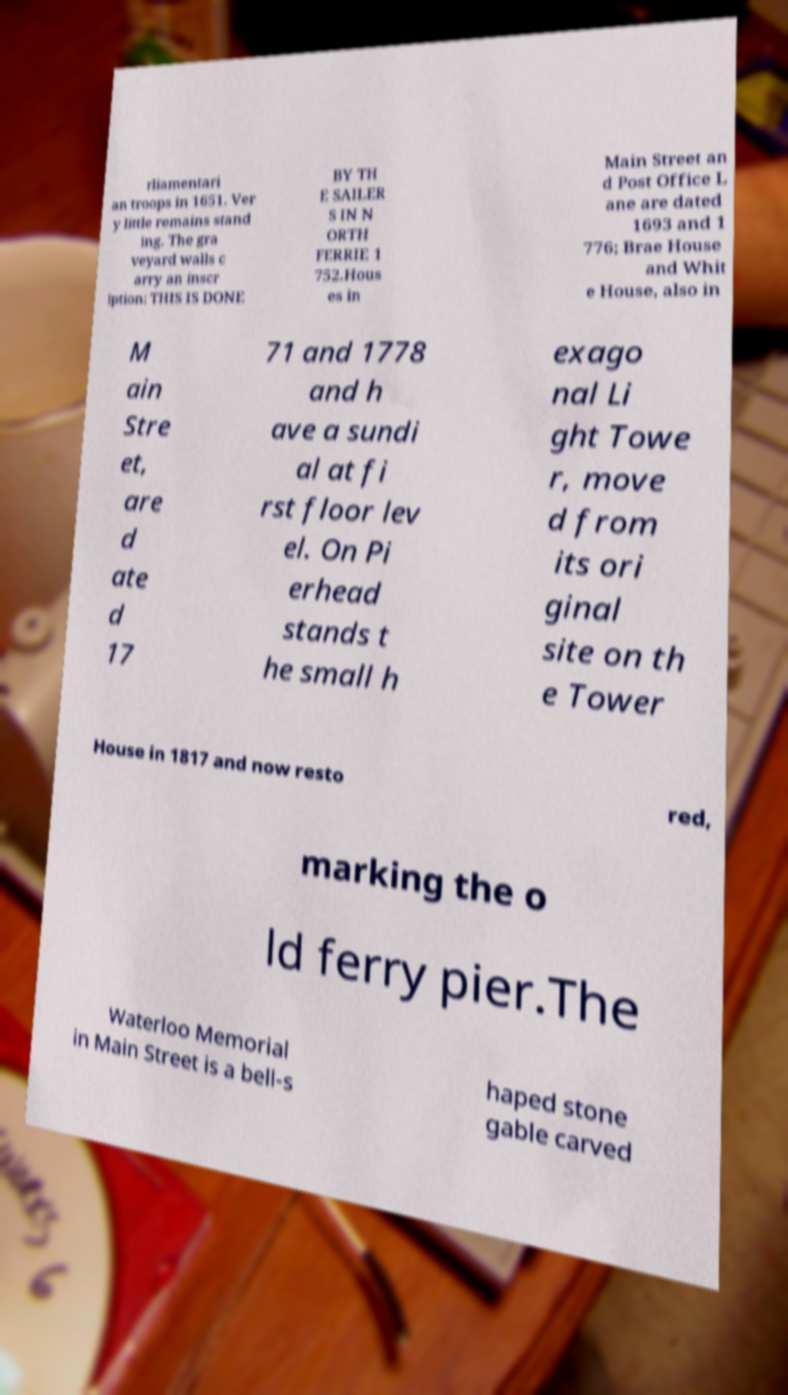Please identify and transcribe the text found in this image. rliamentari an troops in 1651. Ver y little remains stand ing. The gra veyard walls c arry an inscr iption: THIS IS DONE BY TH E SAILER S IN N ORTH FERRIE 1 752.Hous es in Main Street an d Post Office L ane are dated 1693 and 1 776; Brae House and Whit e House, also in M ain Stre et, are d ate d 17 71 and 1778 and h ave a sundi al at fi rst floor lev el. On Pi erhead stands t he small h exago nal Li ght Towe r, move d from its ori ginal site on th e Tower House in 1817 and now resto red, marking the o ld ferry pier.The Waterloo Memorial in Main Street is a bell-s haped stone gable carved 